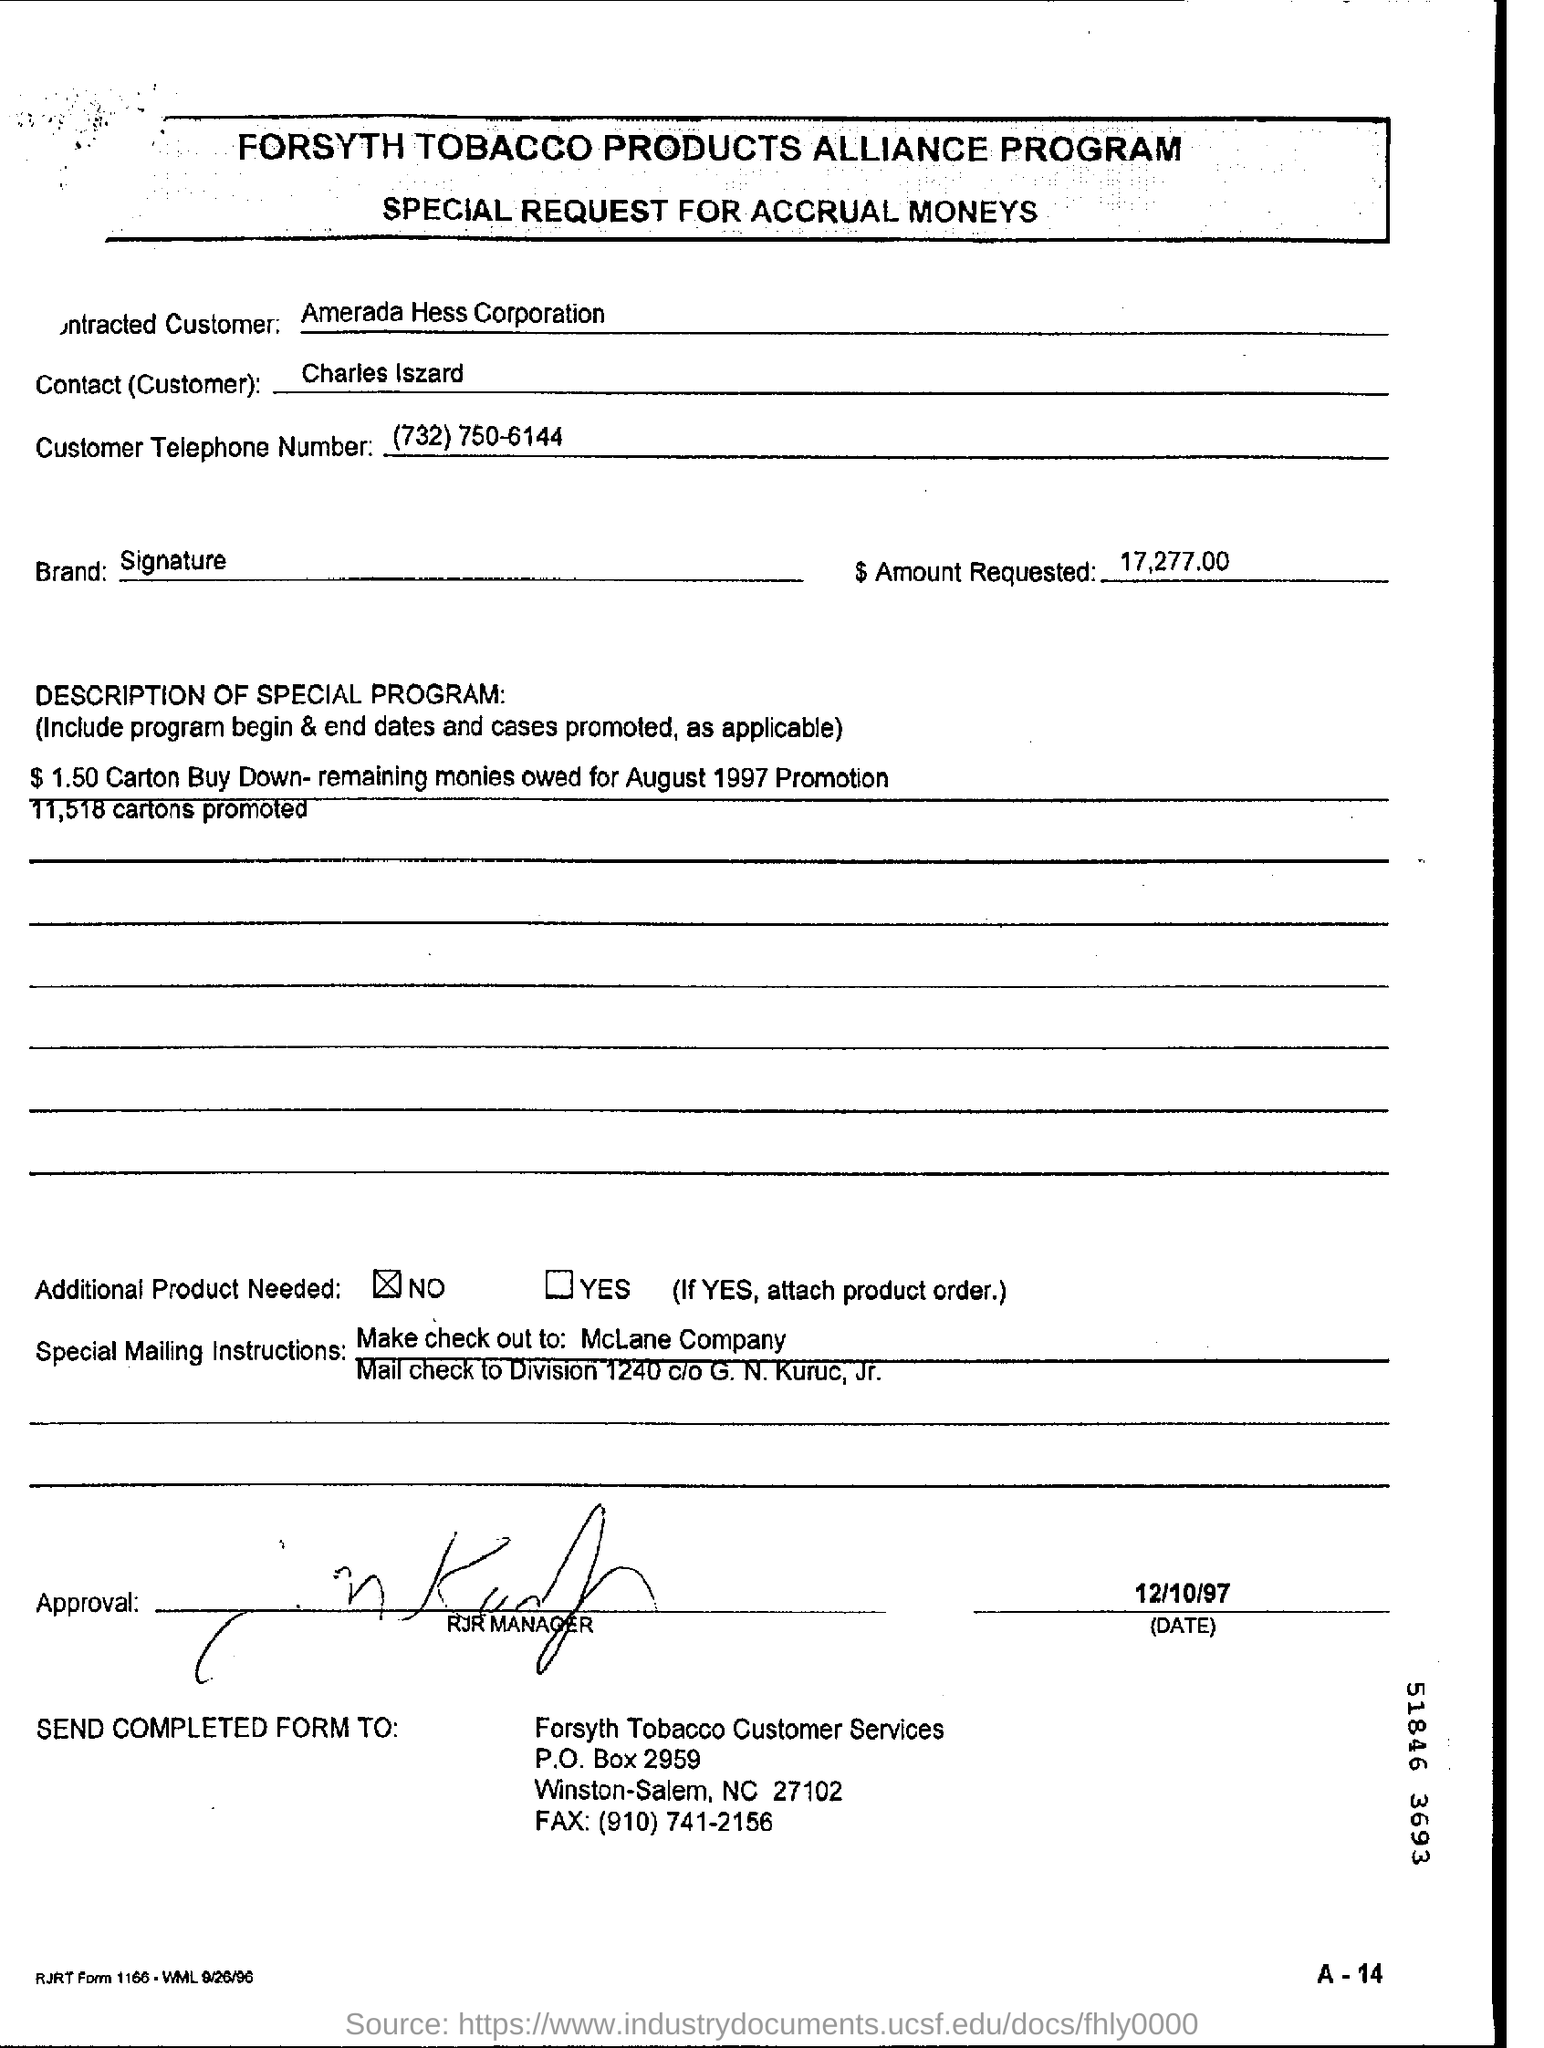What is the amount requested for the tobacco products?
Offer a very short reply. 17,277.00. What is the name of the contact (customer)?
Offer a terse response. Charles Iszard. What is the customers telephone number?
Offer a very short reply. (732) 750-6144. How many number of cartons are promoted?
Provide a short and direct response. 11,158. 